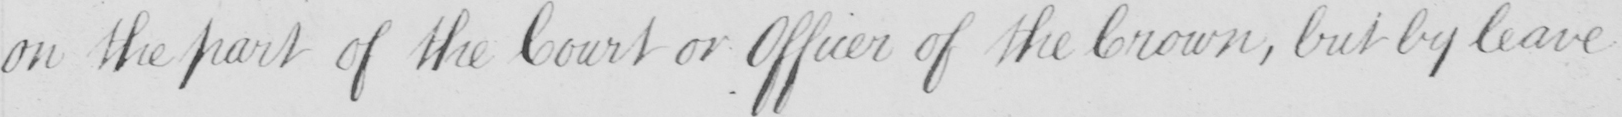What text is written in this handwritten line? on the part of the Court or Officer of the Crown , but by leave 